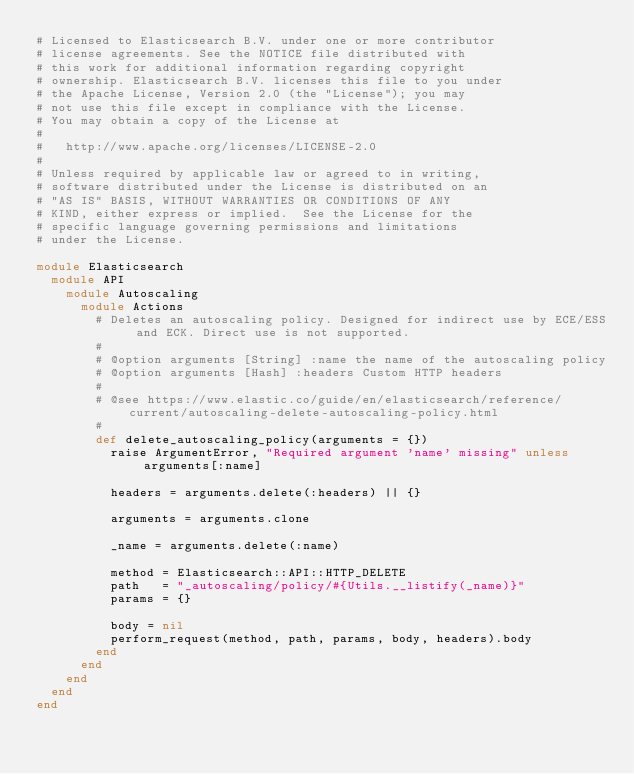Convert code to text. <code><loc_0><loc_0><loc_500><loc_500><_Ruby_># Licensed to Elasticsearch B.V. under one or more contributor
# license agreements. See the NOTICE file distributed with
# this work for additional information regarding copyright
# ownership. Elasticsearch B.V. licenses this file to you under
# the Apache License, Version 2.0 (the "License"); you may
# not use this file except in compliance with the License.
# You may obtain a copy of the License at
#
#   http://www.apache.org/licenses/LICENSE-2.0
#
# Unless required by applicable law or agreed to in writing,
# software distributed under the License is distributed on an
# "AS IS" BASIS, WITHOUT WARRANTIES OR CONDITIONS OF ANY
# KIND, either express or implied.  See the License for the
# specific language governing permissions and limitations
# under the License.

module Elasticsearch
  module API
    module Autoscaling
      module Actions
        # Deletes an autoscaling policy. Designed for indirect use by ECE/ESS and ECK. Direct use is not supported.
        #
        # @option arguments [String] :name the name of the autoscaling policy
        # @option arguments [Hash] :headers Custom HTTP headers
        #
        # @see https://www.elastic.co/guide/en/elasticsearch/reference/current/autoscaling-delete-autoscaling-policy.html
        #
        def delete_autoscaling_policy(arguments = {})
          raise ArgumentError, "Required argument 'name' missing" unless arguments[:name]

          headers = arguments.delete(:headers) || {}

          arguments = arguments.clone

          _name = arguments.delete(:name)

          method = Elasticsearch::API::HTTP_DELETE
          path   = "_autoscaling/policy/#{Utils.__listify(_name)}"
          params = {}

          body = nil
          perform_request(method, path, params, body, headers).body
        end
      end
    end
  end
end
</code> 